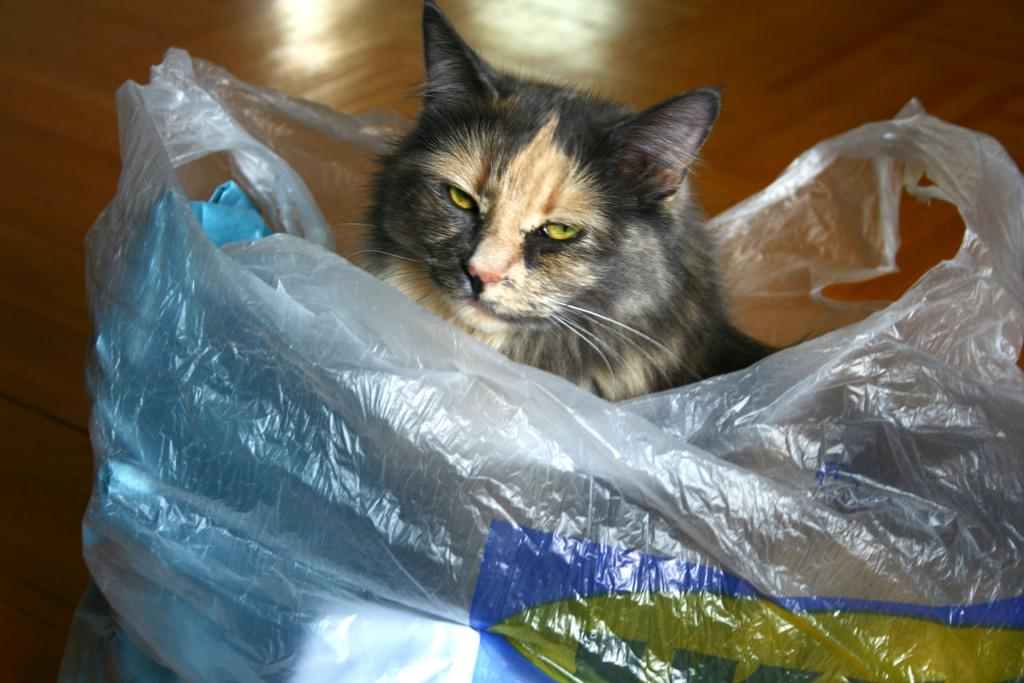What type of animal is present in the image? There is a cat in the image. How is the cat positioned in the image? The cat is inside a cover. What can be seen in the background of the image? There is a floor visible in the background of the image. What type of wound can be seen on the cat's paw in the image? There is no wound visible on the cat's paw in the image. What type of jewel is the cat wearing around its neck in the image? There is no jewel visible around the cat's neck in the image. 